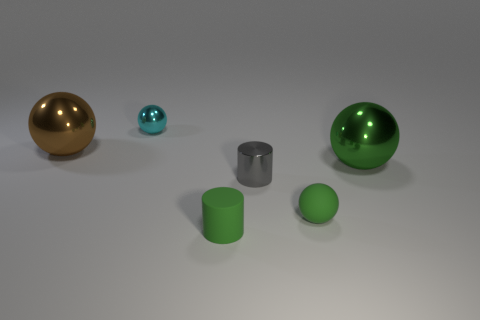Add 2 tiny metal cylinders. How many objects exist? 8 Subtract all green cylinders. Subtract all green blocks. How many cylinders are left? 1 Subtract all cyan cylinders. How many purple balls are left? 0 Subtract all small matte objects. Subtract all gray metal things. How many objects are left? 3 Add 2 gray metallic objects. How many gray metallic objects are left? 3 Add 3 tiny green matte cylinders. How many tiny green matte cylinders exist? 4 Subtract all cyan balls. How many balls are left? 3 Subtract all tiny cyan spheres. How many spheres are left? 3 Subtract 0 blue spheres. How many objects are left? 6 Subtract all cylinders. How many objects are left? 4 